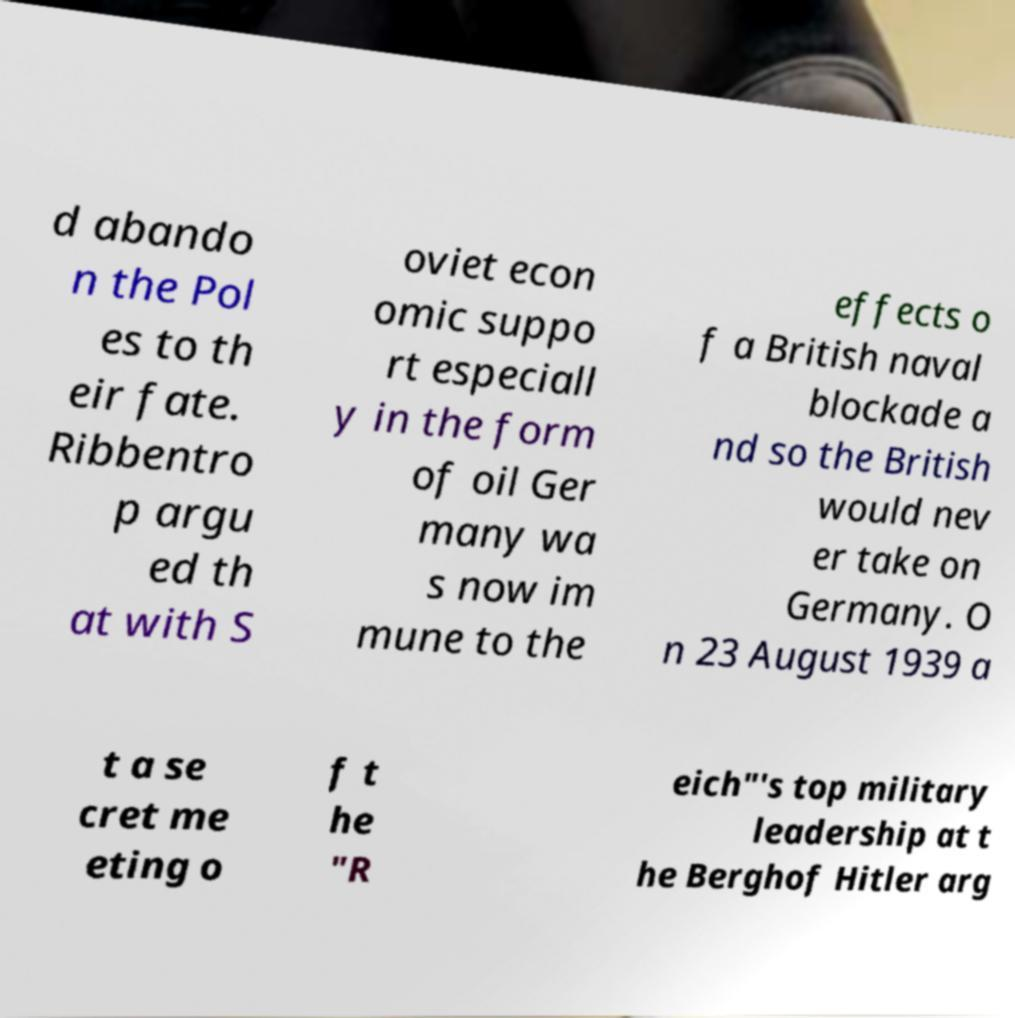What messages or text are displayed in this image? I need them in a readable, typed format. d abando n the Pol es to th eir fate. Ribbentro p argu ed th at with S oviet econ omic suppo rt especiall y in the form of oil Ger many wa s now im mune to the effects o f a British naval blockade a nd so the British would nev er take on Germany. O n 23 August 1939 a t a se cret me eting o f t he "R eich"'s top military leadership at t he Berghof Hitler arg 